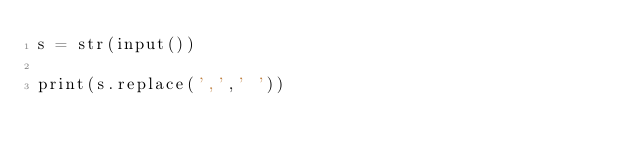Convert code to text. <code><loc_0><loc_0><loc_500><loc_500><_Python_>s = str(input())

print(s.replace(',',' '))
</code> 